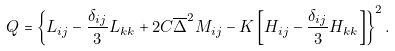Convert formula to latex. <formula><loc_0><loc_0><loc_500><loc_500>Q = \left \{ L _ { i j } - \frac { \delta _ { i j } } { 3 } L _ { k k } + 2 C \overline { \Delta } ^ { 2 } M _ { i j } - K \left [ H _ { i j } - \frac { \delta _ { i j } } { 3 } H _ { k k } \right ] \right \} ^ { 2 } .</formula> 